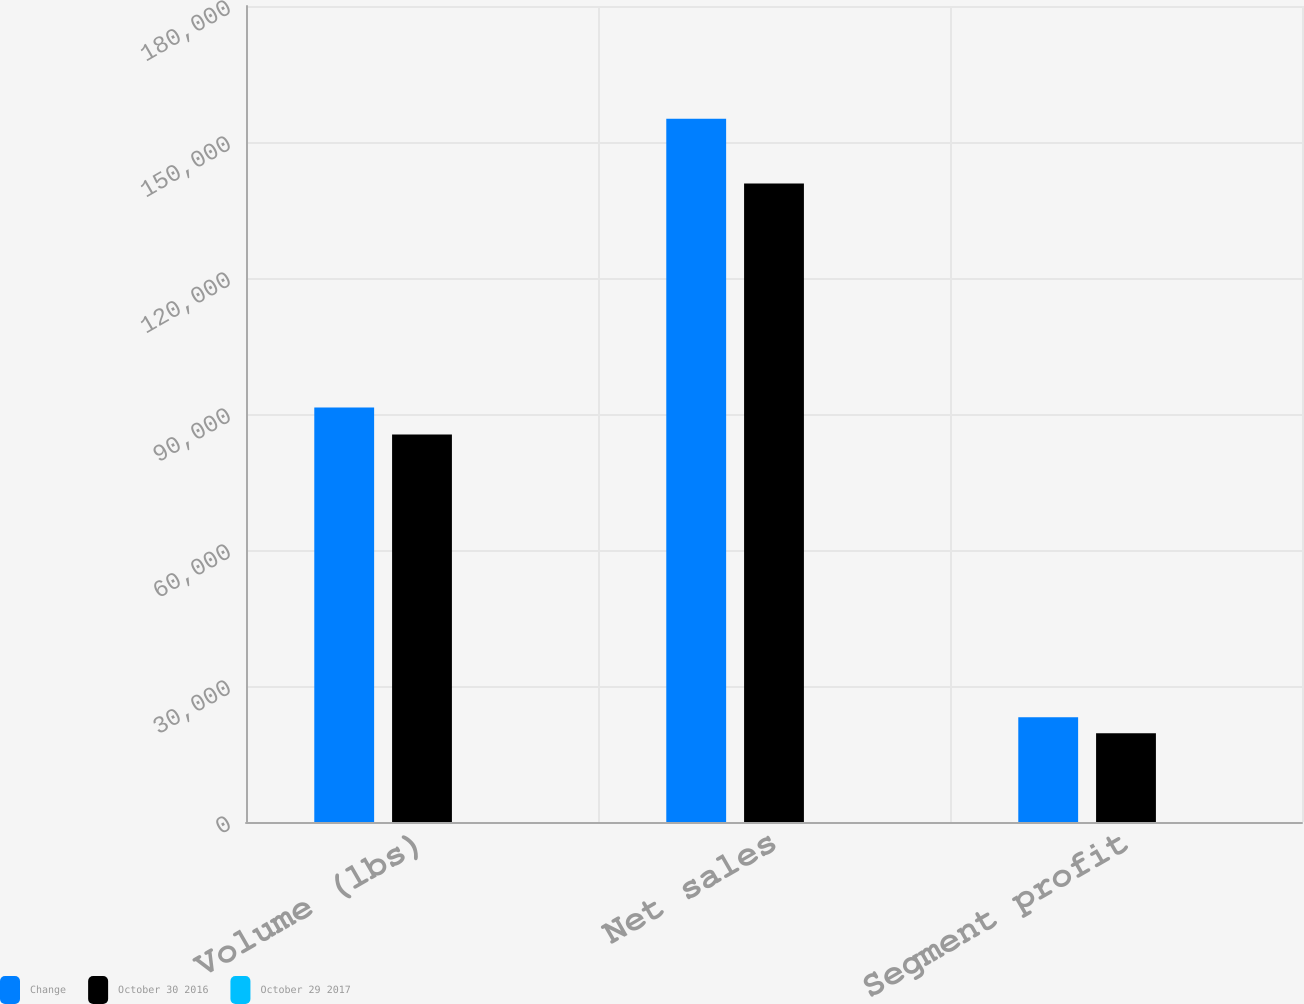Convert chart. <chart><loc_0><loc_0><loc_500><loc_500><stacked_bar_chart><ecel><fcel>Volume (lbs)<fcel>Net sales<fcel>Segment profit<nl><fcel>Change<fcel>91414<fcel>155130<fcel>23113<nl><fcel>October 30 2016<fcel>85454<fcel>140858<fcel>19570<nl><fcel>October 29 2017<fcel>7<fcel>10.1<fcel>18.1<nl></chart> 